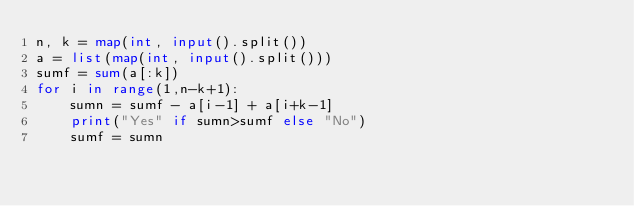Convert code to text. <code><loc_0><loc_0><loc_500><loc_500><_Python_>n, k = map(int, input().split())
a = list(map(int, input().split()))
sumf = sum(a[:k])
for i in range(1,n-k+1):
    sumn = sumf - a[i-1] + a[i+k-1]
    print("Yes" if sumn>sumf else "No")
    sumf = sumn
</code> 